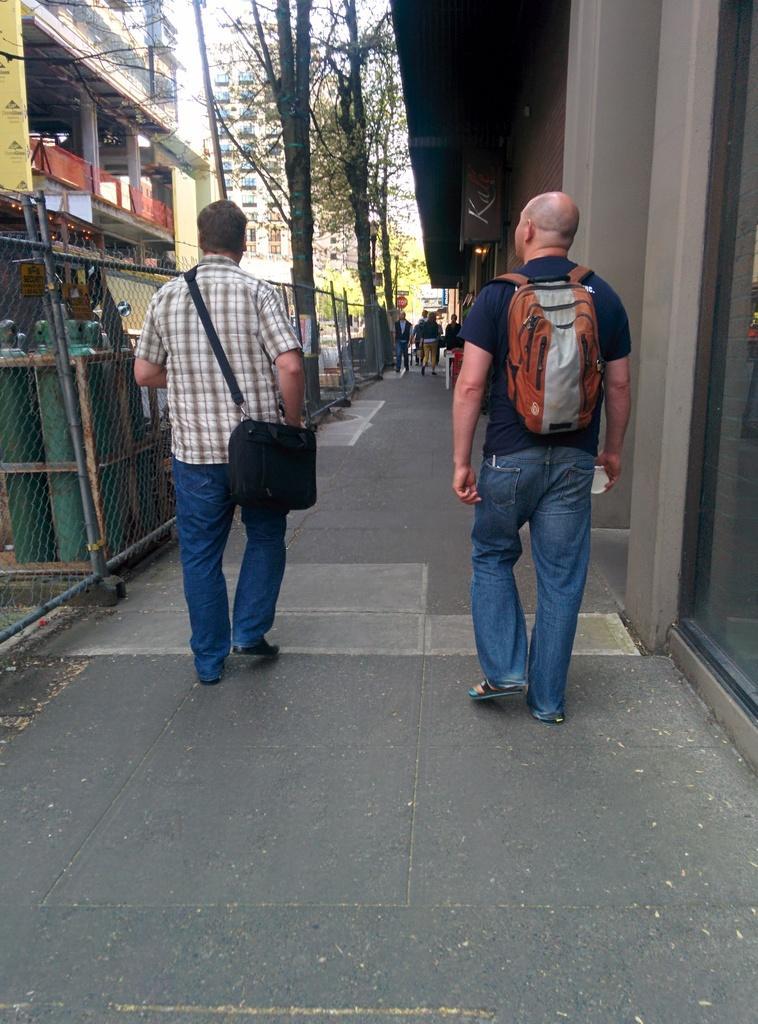How would you summarize this image in a sentence or two? In this image i can see a person's walking on the road. on the right side i can see a person carrying a back pack and his wearing a blue color t-shirt,and on the left side i can see a person with checks shirt and his carrying a black color back pack. on the left can a fence and there is a building and there are some trees on the center. on the middle corner there are the people walking on the road,on the middle another building visible. 